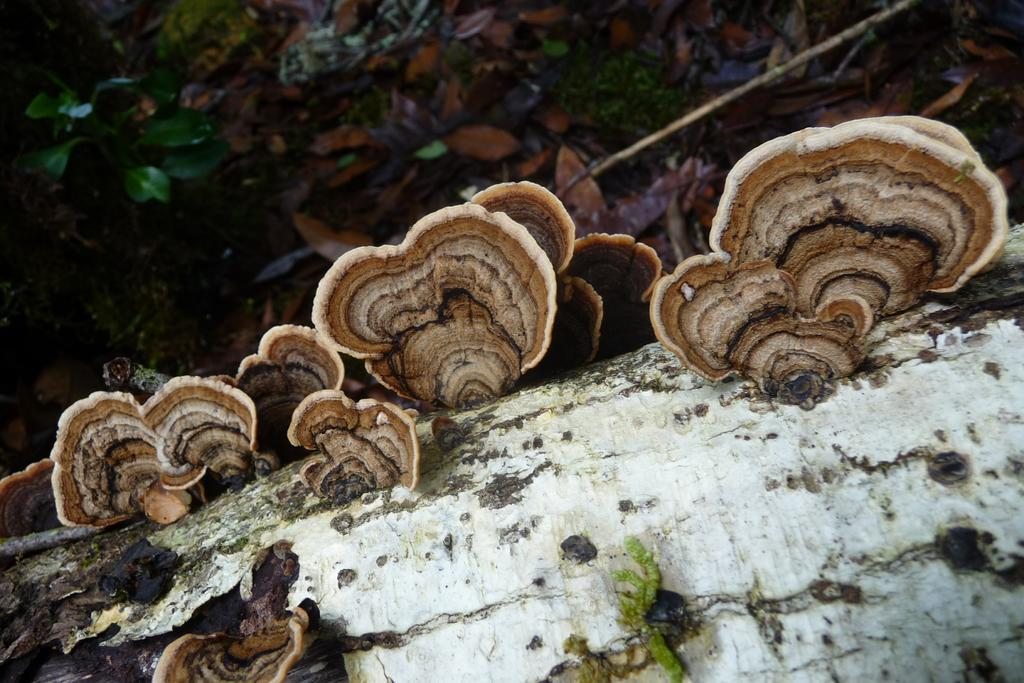What material is present in the image? There is wood in the image. What is growing on the wood? There are mushrooms on the wood. What type of vegetation is visible in the image? Leaves are visible in the image. What type of apparatus is being used to help start the leaves in the image? There is no apparatus or action of starting leaves in the image; the leaves are simply visible. 